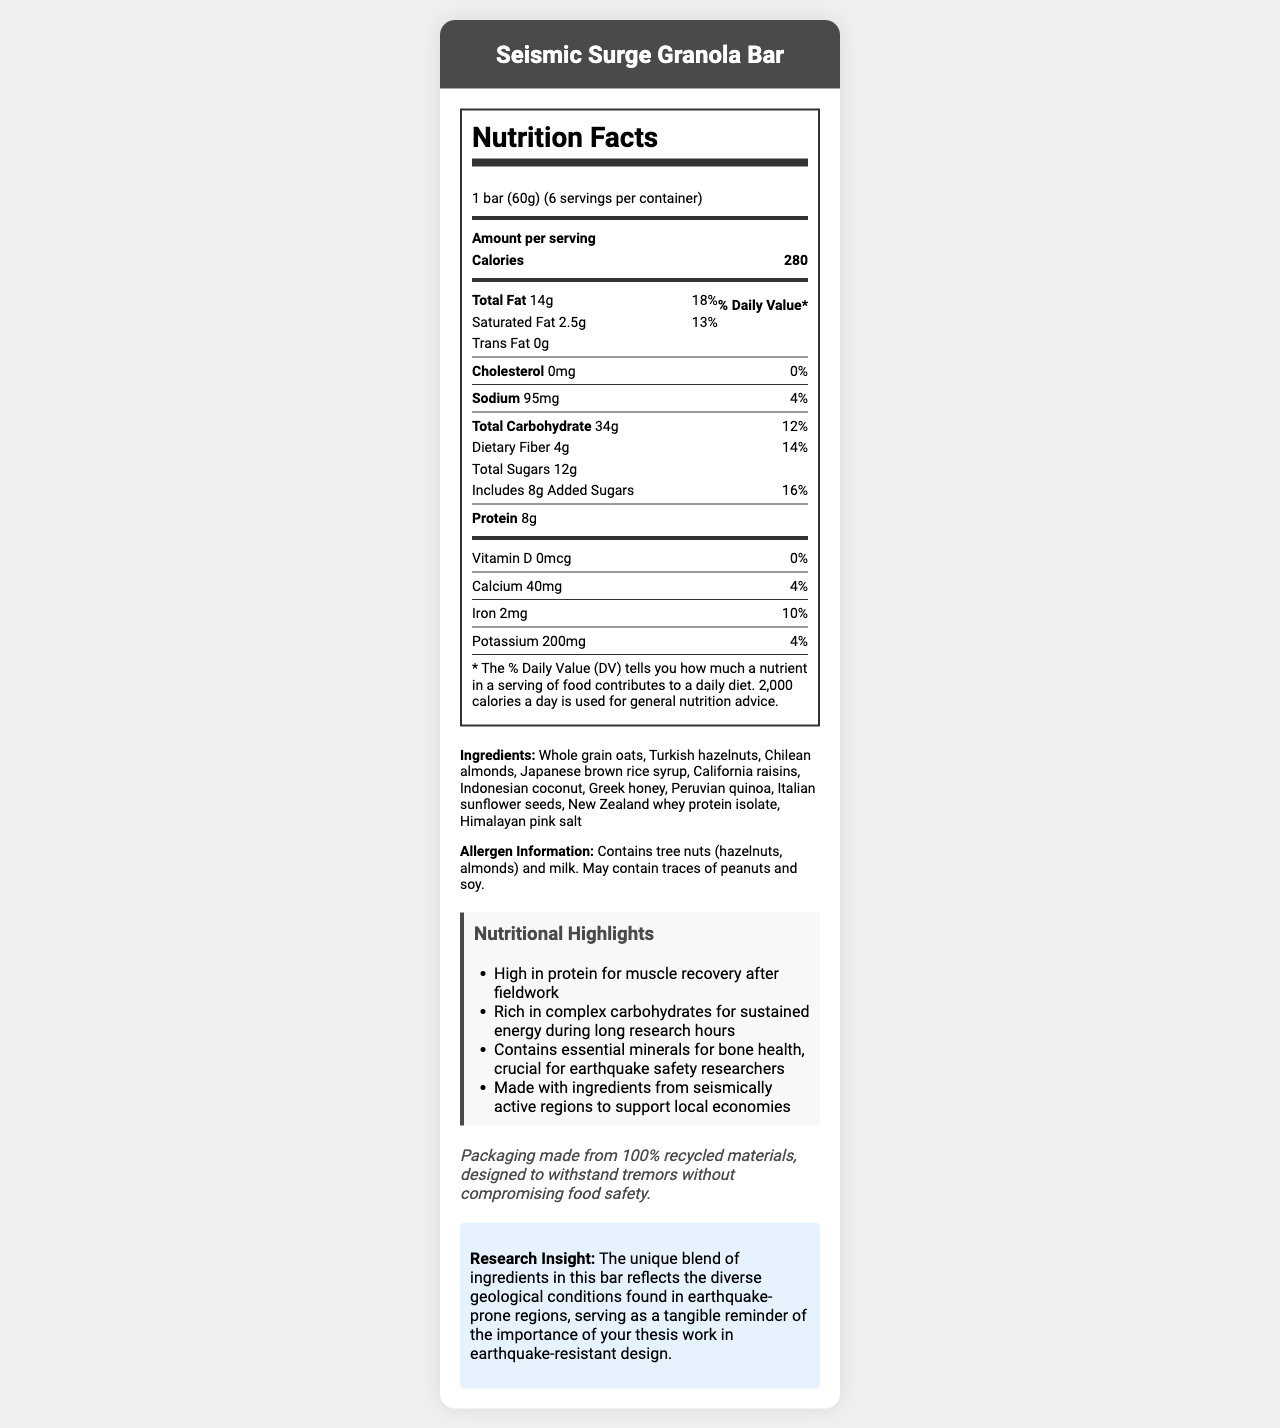what is the serving size of the Seismic Surge Granola Bar? The document mentions that the serving size is "1 bar (60g)" under the Nutrition Facts section.
Answer: 1 bar (60g) how many calories are there per serving? The label explicitly states that there are 280 calories per serving.
Answer: 280 what is the amount of protein per serving? The Nutrition Facts section lists 8g of protein per serving.
Answer: 8g how much added sugar is in one serving? The amount of added sugars is listed as 8g per serving in the Nutrition Facts section.
Answer: 8g which ingredients are sourced from regions prone to earthquakes? The list of ingredients mentions the origin of each component, many from seismically active regions.
Answer: Turkish hazelnuts, Chilean almonds, Japanese brown rice syrup, California raisins, Indonesian coconut, Greek honey, Peruvian quinoa, Italian sunflower seeds, New Zealand whey protein isolate, Himalayan pink salt how many servings are there per container? The document states that there are 6 servings per container.
Answer: 6 what is the daily value percentage of iron? The Nutrition Facts section indicates that the daily value percentage for iron is 10%.
Answer: 10% which nutrient has the highest daily value percentage? A. Total Fat B. Sodium C. Total Carbohydrate D. Dietary Fiber The document lists Total Fat with a daily value percentage of 18%, which is higher than Sodium (4%), Total Carbohydrate (12%), and Dietary Fiber (14%).
Answer: A. Total Fat what is the main source of sweetness in the granola bar? A. Greek honey B. Japanese brown rice syrup C. California raisins D. All of the above The ingredients include Greek honey, Japanese brown rice syrup, and California raisins, all of which provide sweetness.
Answer: D. All of the above does the granola bar contain Vitamin D? The Vitamin D amount is listed as 0mcg with a 0% daily value, indicating it does not contain Vitamin D.
Answer: No summarize the main idea of the document. This document focuses on presenting the nutritional facts, highlighting the benefits, mentioning the origin of ingredients, and underlining the sustainable packaging of the Seismic Surge Granola Bar.
Answer: The document provides detailed nutrition information, ingredients, and additional highlights for the Seismic Surge Granola Bar. It emphasizes the bar's nutritional benefits, ingredients sourced from earthquake-prone regions, and its sustainable packaging. what kind of tree nuts are included in the granola bar? The allergen information specifies that the bar contains tree nuts, specifically hazelnuts and almonds.
Answer: Hazelnuts and almonds how much calcium is in one serving? The Nutrition Facts section lists the amount of calcium per serving as 40mg.
Answer: 40mg what is the purpose of the sustainability note? The sustainability note in the document mentions this information about the packaging.
Answer: To inform that the packaging is made from 100% recycled materials and is designed to withstand tremors without compromising food safety how does this product support your research on earthquake-resistant design? The research insight explains the connection between the bar’s ingredients and packaging with earthquake-prone regions and the importance of earthquake-resistant design.
Answer: It uses ingredients from seismically active regions and has packaging designed to withstand tremors, providing a tangible connection to the importance of research in earthquake-resistant design. where are the ingredients sourced from? The document lists several countries like Turkey, Chile, Japan, California (USA), Indonesia, Greece, Peru, Italy, New Zealand, and Himalayan region, but it does not specify exact sourcing practices or locations beyond countries/regions.
Answer: Cannot be determined 